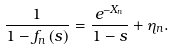<formula> <loc_0><loc_0><loc_500><loc_500>\frac { 1 } { 1 - f _ { n } \left ( s \right ) } = \frac { e ^ { - X _ { n } } } { 1 - s } + \eta _ { n } .</formula> 